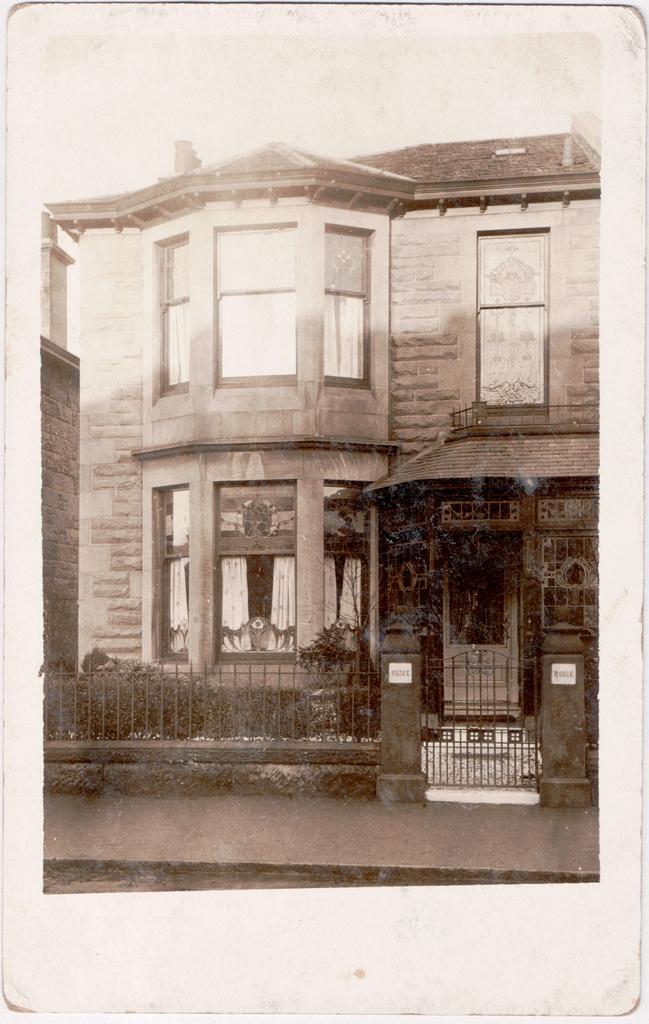Can you describe this image briefly? In this picture there is a building in the background. In front of the building there are plants and there is a fence and a gate. 